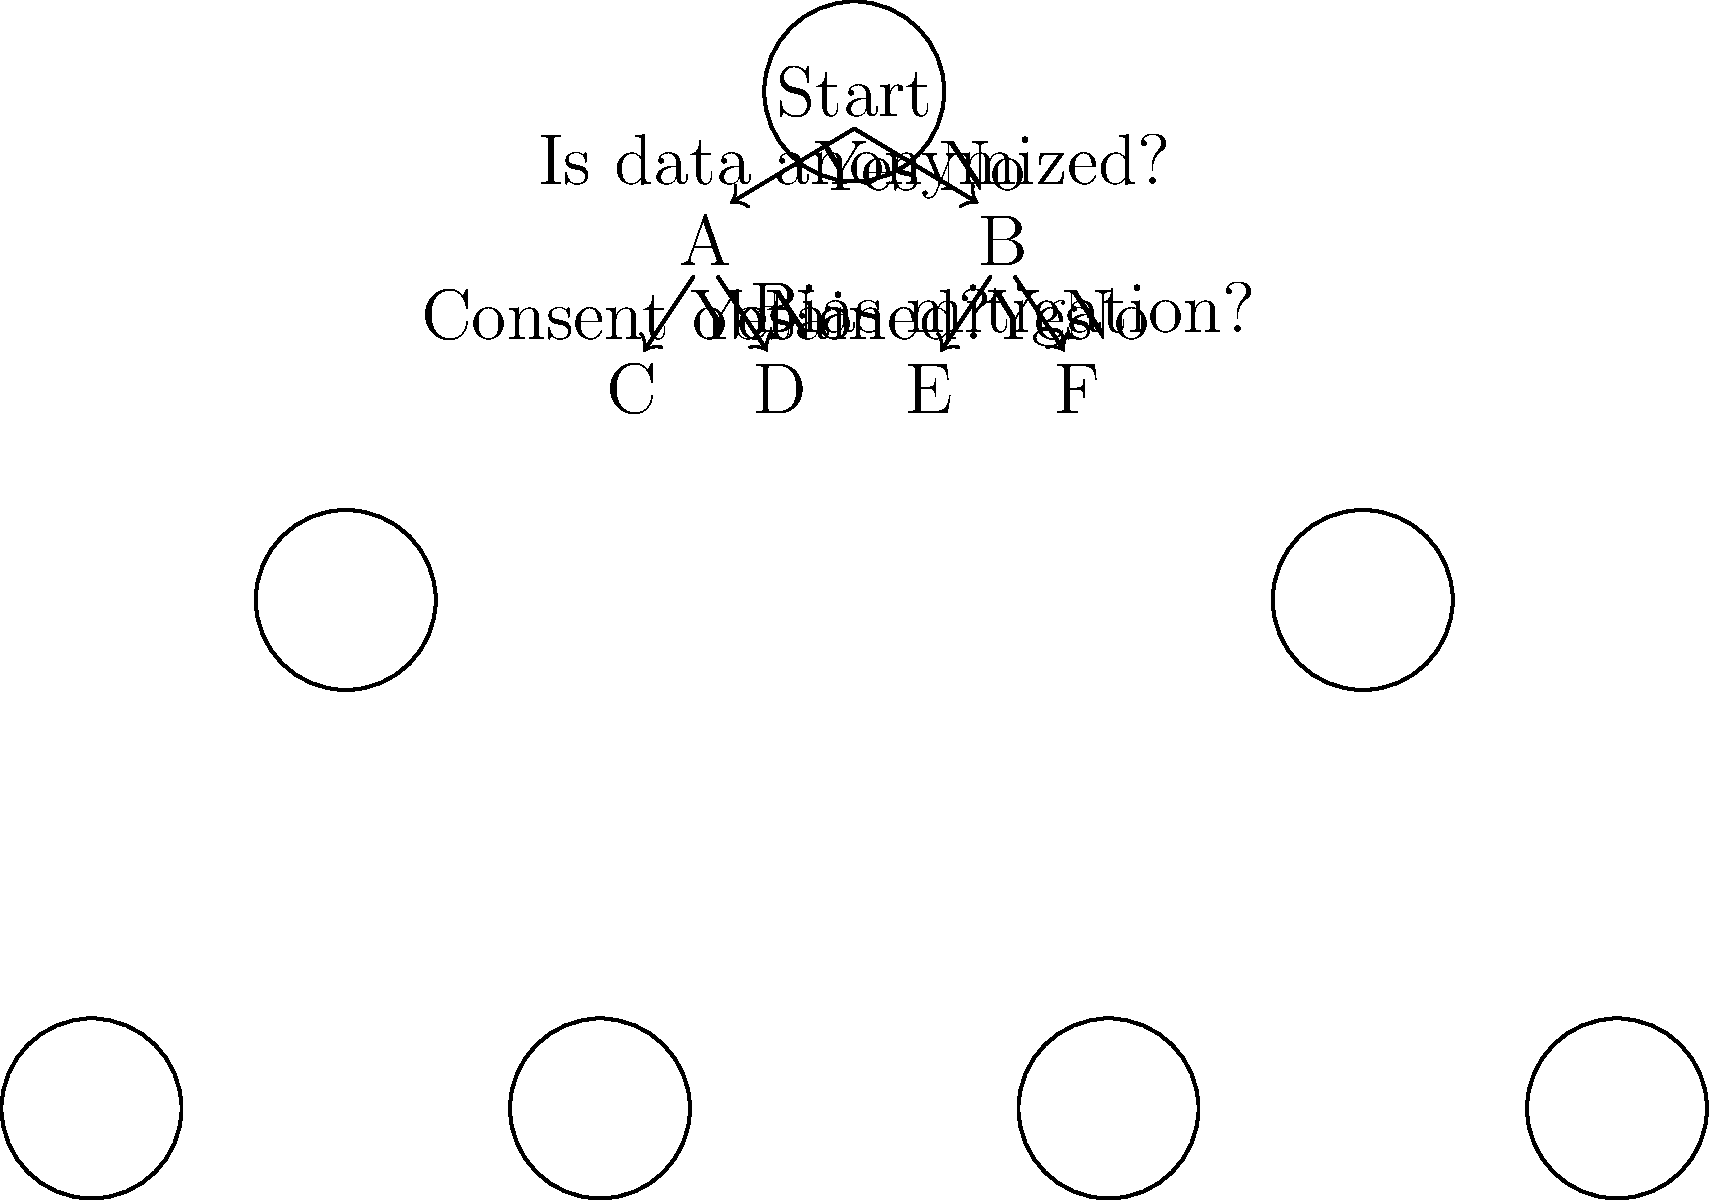In the decision tree diagram for an ethical AI decision-making process, what is the outcome if the data is not anonymized, but bias mitigation measures are implemented? To determine the outcome based on the given conditions, let's follow the decision tree step-by-step:

1. The first decision point asks, "Is data anonymized?"
   - Given condition: data is not anonymized
   - We follow the "No" branch to node B

2. At node B, the question is "Bias mitigation?"
   - Given condition: bias mitigation measures are implemented
   - We follow the "Yes" branch

3. This leads us to the final outcome, which is node E

Therefore, when the data is not anonymized but bias mitigation measures are implemented, the ethical AI decision-making process leads to outcome E.
Answer: E 